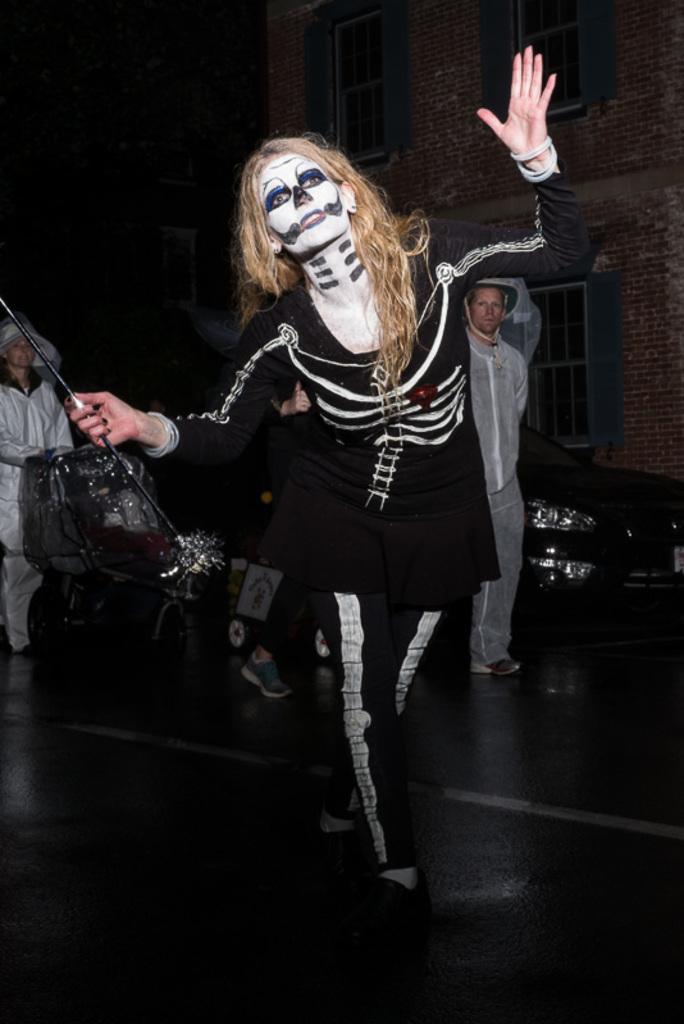Could you give a brief overview of what you see in this image? There is a woman in motion and holding a stick. In the background we can see people,windows,wall and car. 